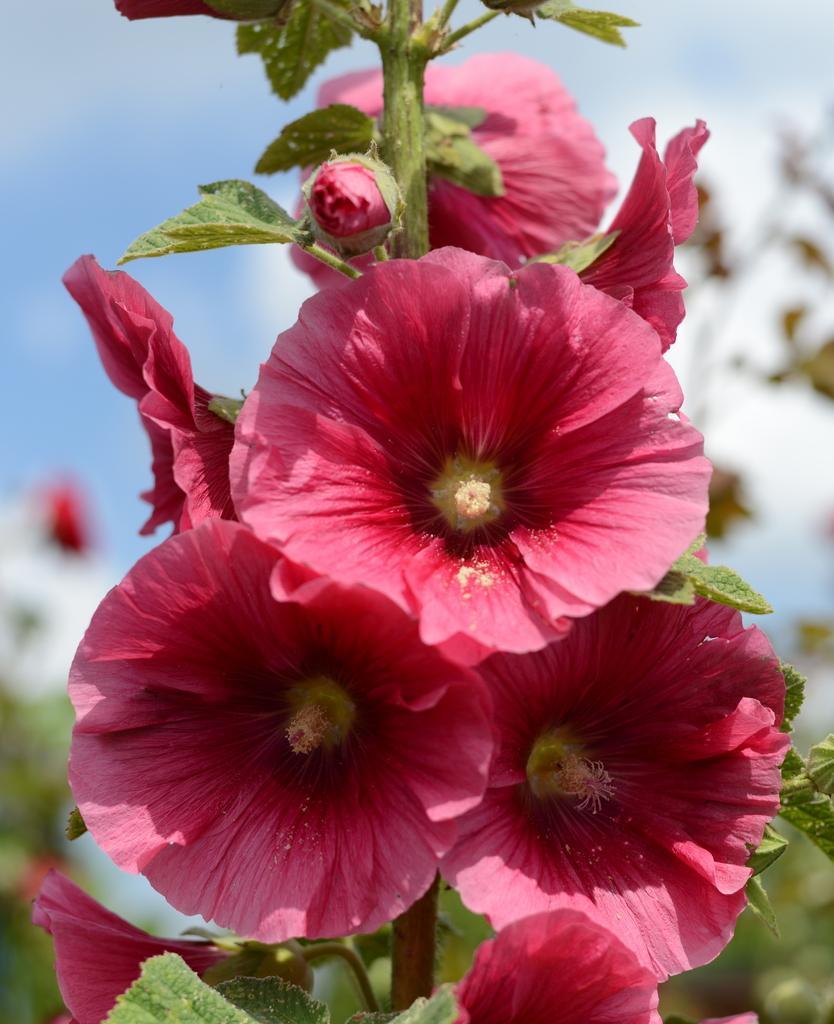Can you describe this image briefly? In this picture we can see few flowers and plants. 